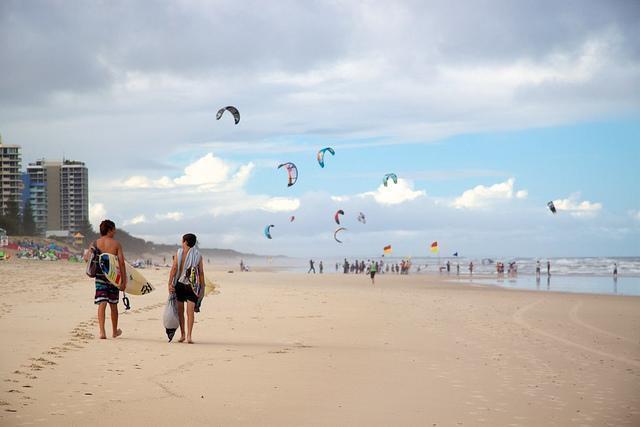How many people are in the photo?
Give a very brief answer. 2. 